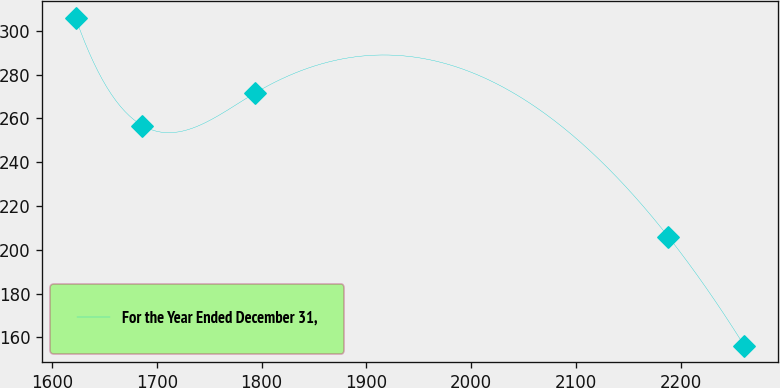Convert chart. <chart><loc_0><loc_0><loc_500><loc_500><line_chart><ecel><fcel>For the Year Ended December 31,<nl><fcel>1622.39<fcel>305.99<nl><fcel>1686.22<fcel>256.73<nl><fcel>1794.15<fcel>271.71<nl><fcel>2188.14<fcel>206<nl><fcel>2260.68<fcel>156.22<nl></chart> 